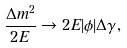Convert formula to latex. <formula><loc_0><loc_0><loc_500><loc_500>\frac { \Delta m ^ { 2 } } { 2 E } \rightarrow 2 E | \phi | \Delta \gamma ,</formula> 